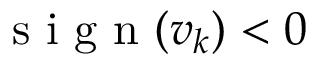<formula> <loc_0><loc_0><loc_500><loc_500>s i g n ( v _ { k } ) < 0</formula> 